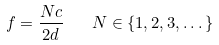Convert formula to latex. <formula><loc_0><loc_0><loc_500><loc_500>f = { \frac { N c } { 2 d } } \quad N \in \{ 1 , 2 , 3 , \dots \}</formula> 